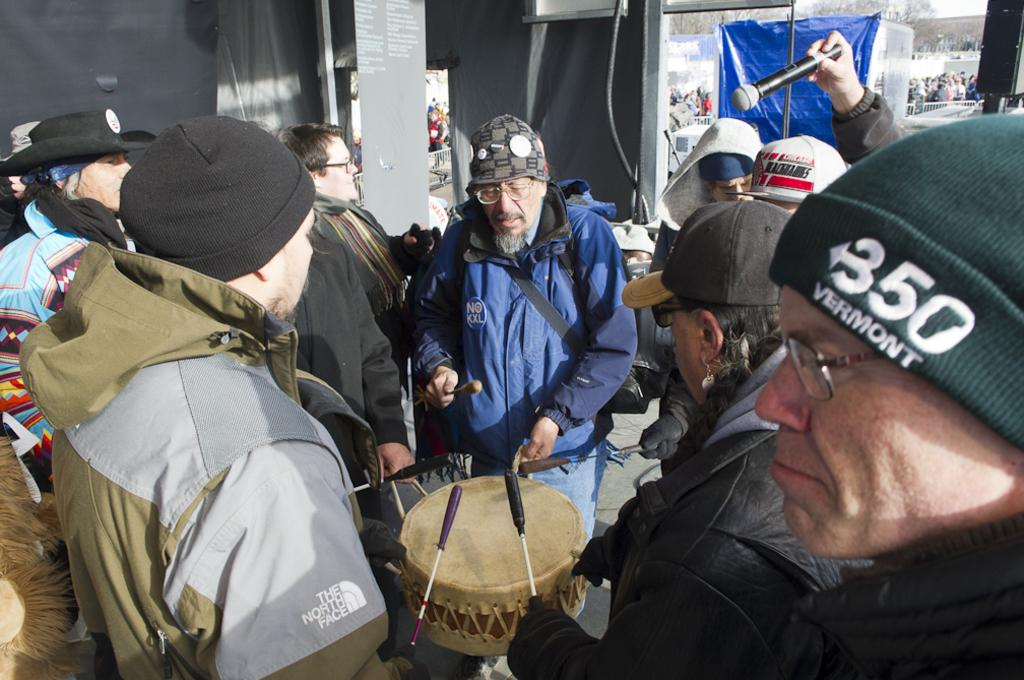What is happening in the image involving the group of people? The people in the image are standing and playing musical instruments. Can you describe the presence of a microphone in the image? Yes, there is a microphone in the image. What else can be seen in the background of the image? There are people visible in the background of the image. What other equipment might be used for amplifying sound in the image? There appears to be a speaker in the image. Can you see the moon in the image? No, the moon is not visible in the image. What type of yarn is being used by the people playing musical instruments? There is no yarn present in the image; the people are playing musical instruments with their hands or other equipment. 